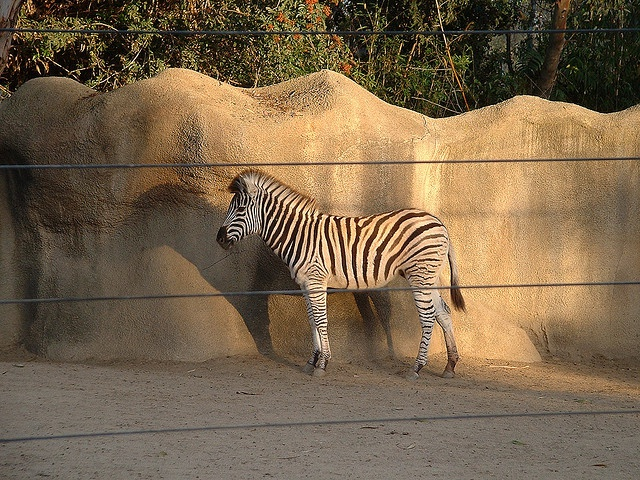Describe the objects in this image and their specific colors. I can see a zebra in gray, black, tan, and maroon tones in this image. 